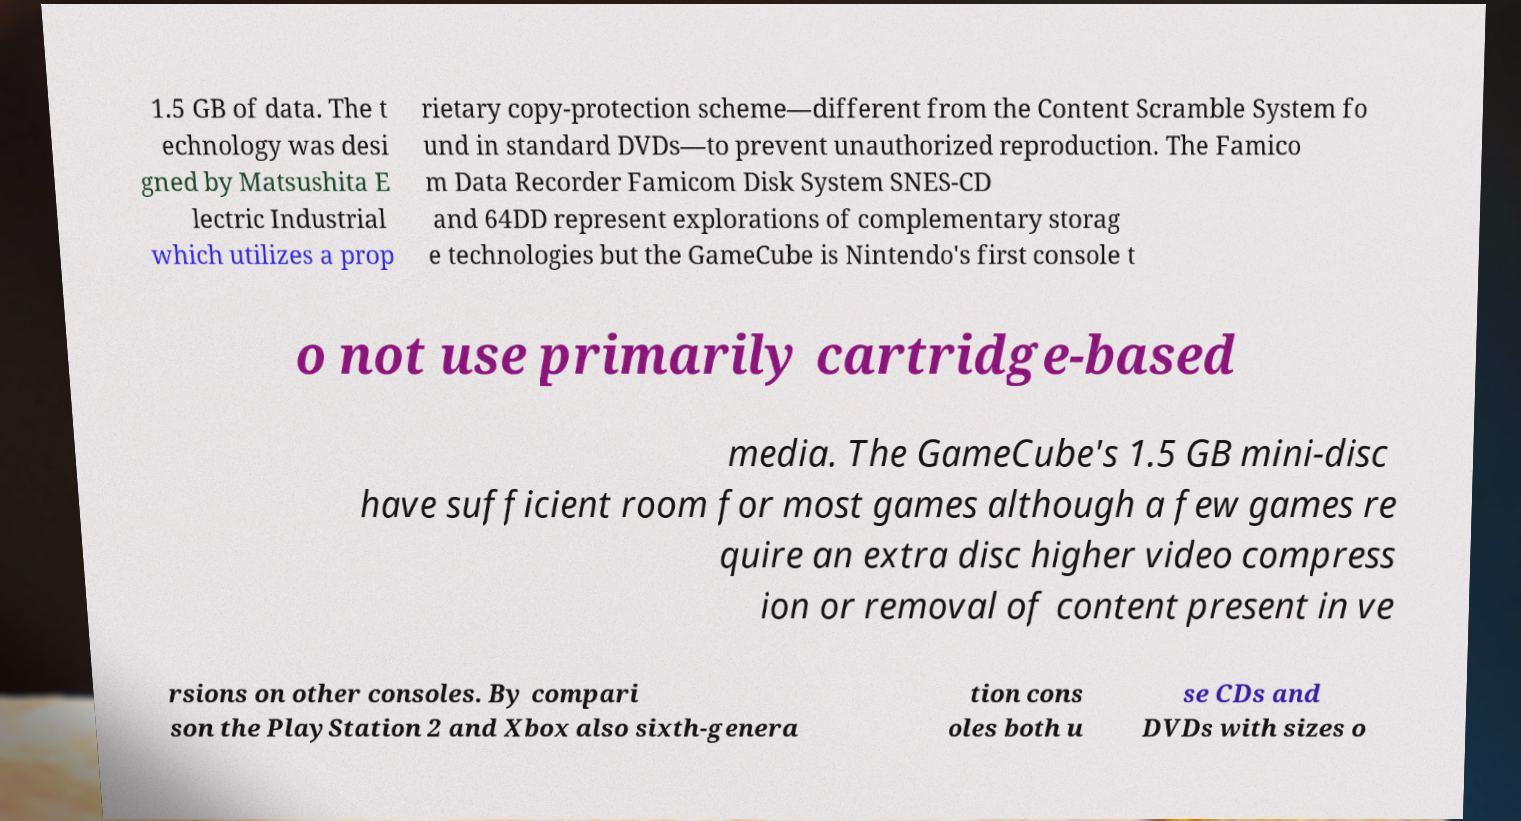Please read and relay the text visible in this image. What does it say? 1.5 GB of data. The t echnology was desi gned by Matsushita E lectric Industrial which utilizes a prop rietary copy-protection scheme—different from the Content Scramble System fo und in standard DVDs—to prevent unauthorized reproduction. The Famico m Data Recorder Famicom Disk System SNES-CD and 64DD represent explorations of complementary storag e technologies but the GameCube is Nintendo's first console t o not use primarily cartridge-based media. The GameCube's 1.5 GB mini-disc have sufficient room for most games although a few games re quire an extra disc higher video compress ion or removal of content present in ve rsions on other consoles. By compari son the PlayStation 2 and Xbox also sixth-genera tion cons oles both u se CDs and DVDs with sizes o 